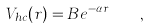Convert formula to latex. <formula><loc_0><loc_0><loc_500><loc_500>V _ { h c } ( r ) = B e ^ { - \alpha r } \quad ,</formula> 